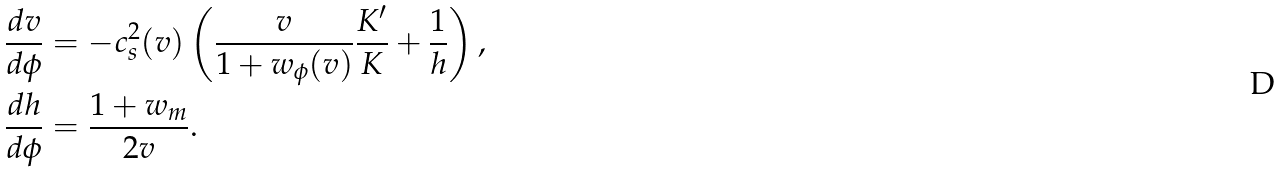Convert formula to latex. <formula><loc_0><loc_0><loc_500><loc_500>\frac { d v } { d \phi } & = - c _ { s } ^ { 2 } ( v ) \left ( \frac { v } { 1 + w _ { \phi } ( v ) } \frac { K ^ { \prime } } { K } + \frac { 1 } { h } \right ) , \\ \frac { d h } { d \phi } & = \frac { 1 + w _ { m } } { 2 v } .</formula> 